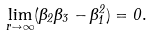Convert formula to latex. <formula><loc_0><loc_0><loc_500><loc_500>\lim _ { r \to \infty } ( \Theta _ { 2 } \Theta _ { 3 } - \Theta _ { 1 } ^ { 2 } ) = 0 .</formula> 